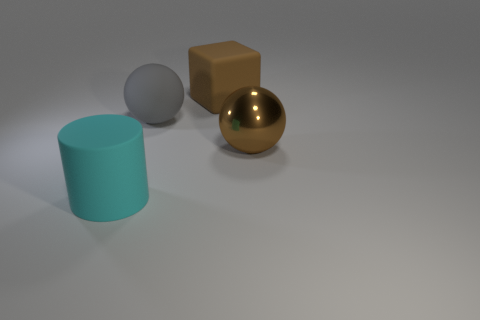The cube that is the same material as the cyan object is what color?
Make the answer very short. Brown. Is the number of rubber blocks in front of the large brown sphere greater than the number of big cyan matte objects in front of the large rubber cylinder?
Make the answer very short. No. Is there a big matte cylinder?
Ensure brevity in your answer.  Yes. There is a large thing that is the same color as the large cube; what material is it?
Offer a terse response. Metal. How many objects are brown metal objects or big matte cylinders?
Make the answer very short. 2. Are there any large cubes that have the same color as the matte ball?
Keep it short and to the point. No. There is a ball behind the large metallic object; how many spheres are right of it?
Provide a succinct answer. 1. Is the number of things greater than the number of yellow metal spheres?
Provide a short and direct response. Yes. Is the material of the large block the same as the big cyan thing?
Give a very brief answer. Yes. Are there the same number of large brown metallic balls that are on the right side of the rubber block and red matte spheres?
Keep it short and to the point. No. 